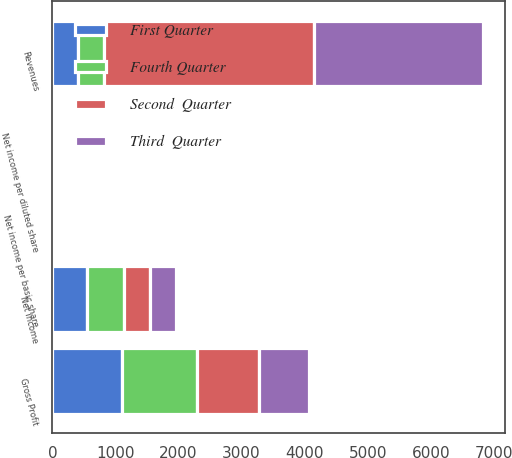Convert chart to OTSL. <chart><loc_0><loc_0><loc_500><loc_500><stacked_bar_chart><ecel><fcel>Revenues<fcel>Gross Profit<fcel>Net income<fcel>Net income per basic share<fcel>Net income per diluted share<nl><fcel>Third  Quarter<fcel>2685.4<fcel>796.6<fcel>397.6<fcel>1.12<fcel>1.11<nl><fcel>Second  Quarter<fcel>3324.2<fcel>981.5<fcel>421.7<fcel>1.05<fcel>1.04<nl><fcel>First Quarter<fcel>409.65<fcel>1100<fcel>547.7<fcel>1.32<fcel>1.31<nl><fcel>Fourth Quarter<fcel>409.65<fcel>1193.4<fcel>585<fcel>1.41<fcel>1.4<nl></chart> 